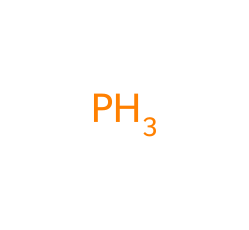What is the central atom in this chemical structure? The chemical structure indicates a single phosphorus atom. The whole structure revolves around this central atom, confirming that phosphorus is the key component here.
Answer: phosphorus How many hydrogen atoms are typically associated with phosphine? Phosphine usually bonds with three hydrogen atoms, as indicated by its general formula PH3. This structure suggests the presence of three hydrogen atoms connected to the phosphorus atom.
Answer: three What is the molecular formula of phosphine? The molecular formula for phosphine, represented by its atoms, is PH3, which includes one phosphorus atom and three hydrogen atoms.
Answer: PH3 What type of compound is phosphine? Phosphine is classified as a phosphorous hydride due to its composition of phosphorus and hydrogen. This name reflects the bonding and gives insight into its properties.
Answer: phosphine What is a common use for phosphine in rural settings? Phosphine is often used as a fumigant in rodent control products to manage pests. Its efficacy in pest management has made it a popular choice in those contexts.
Answer: rodent control 